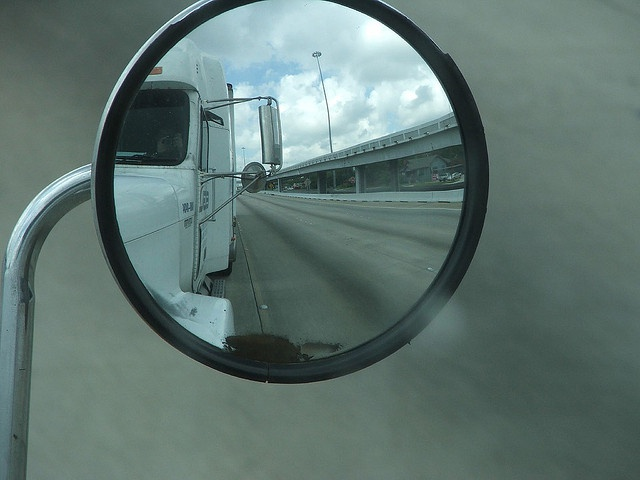Describe the objects in this image and their specific colors. I can see truck in black, gray, lightblue, and teal tones and people in black and purple tones in this image. 